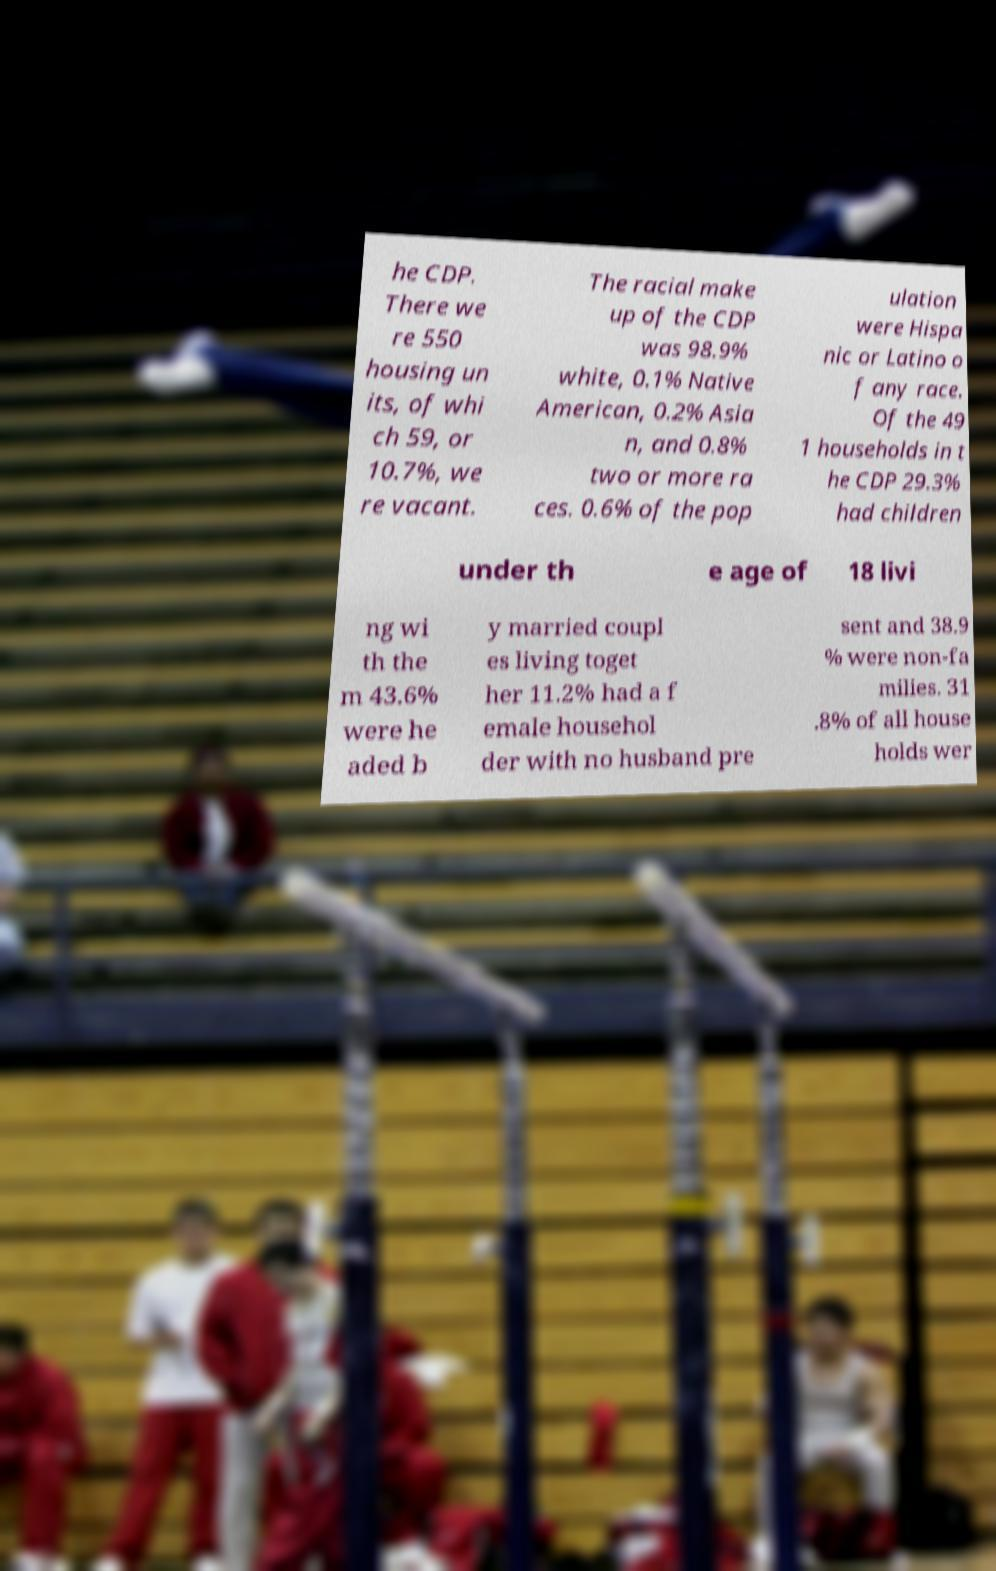Please read and relay the text visible in this image. What does it say? he CDP. There we re 550 housing un its, of whi ch 59, or 10.7%, we re vacant. The racial make up of the CDP was 98.9% white, 0.1% Native American, 0.2% Asia n, and 0.8% two or more ra ces. 0.6% of the pop ulation were Hispa nic or Latino o f any race. Of the 49 1 households in t he CDP 29.3% had children under th e age of 18 livi ng wi th the m 43.6% were he aded b y married coupl es living toget her 11.2% had a f emale househol der with no husband pre sent and 38.9 % were non-fa milies. 31 .8% of all house holds wer 